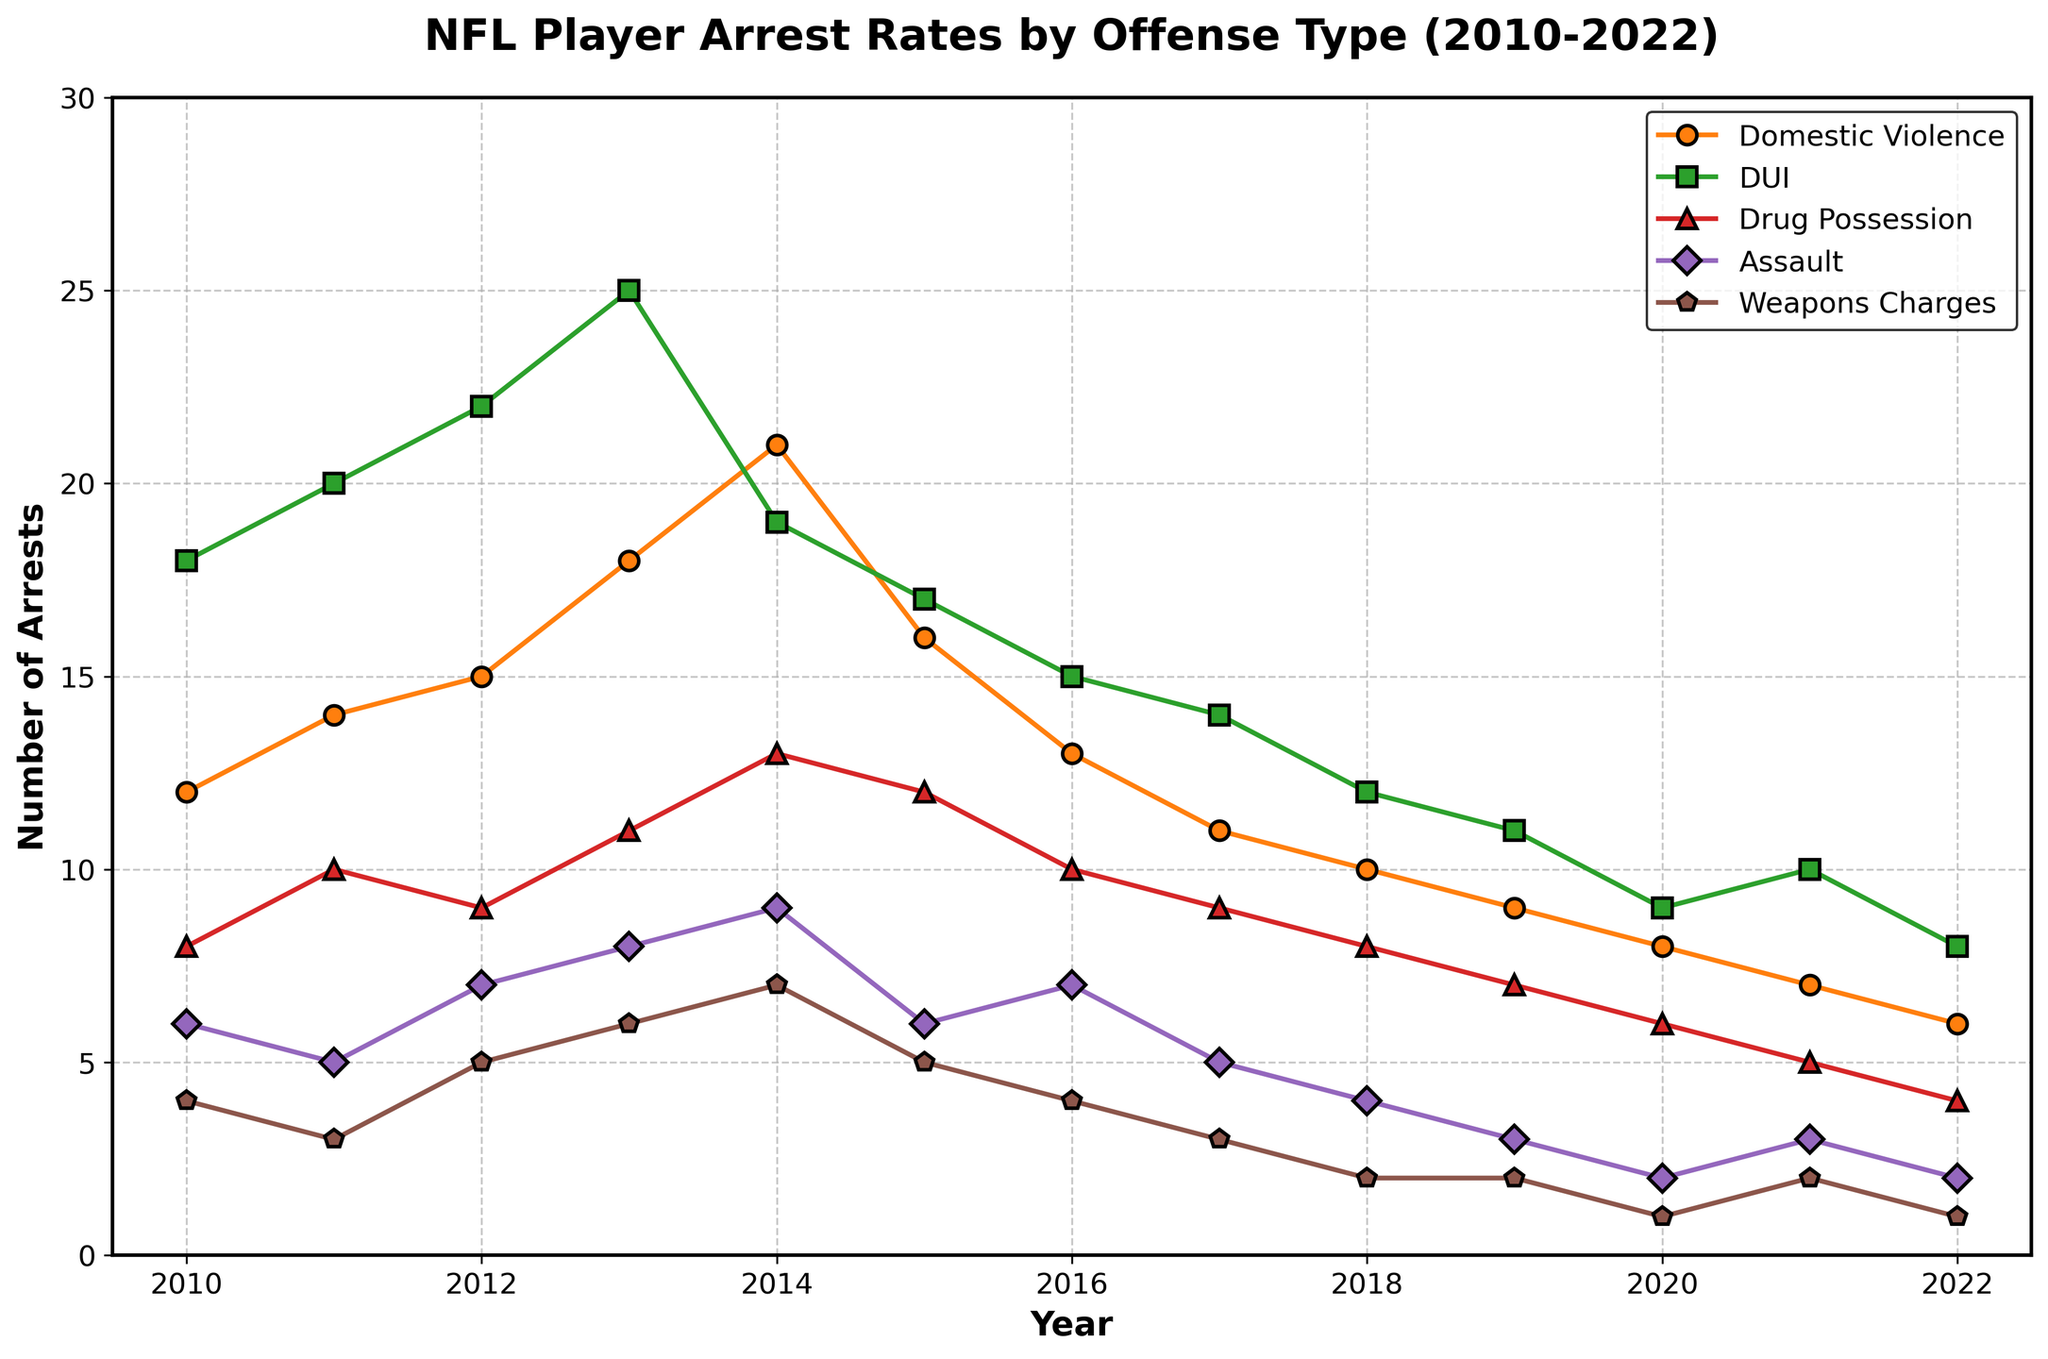How did the number of DUI arrests change from 2010 to 2022? To find the change in the number of DUI arrests, subtract the number of arrests in 2022 (8) from the number of arrests in 2010 (18). 18 - 8 = 10.
Answer: The number of DUI arrests decreased by 10 Which offense had the highest arrest rate in 2013? Examine the peak values for each offense in 2013. Domestic Violence had 18, DUI had 25, Drug Possession had 11, Assault had 8, and Weapons Charges had 6. The highest value is 25 for DUI.
Answer: DUI What is the sum of Domestic Violence arrests from 2010 to 2015? Add the number of Domestic Violence arrests for each year from 2010 to 2015: 12 + 14 + 15 + 18 + 21 + 16 = 96.
Answer: 96 Which offense consistently shows the lowest number of arrests each year? Compare the number of arrests for each offense across all years. Weapons Charges has the lowest arrest numbers in each year (4, 3, 5, 6, 7, 5, 4, 3, 2, 2, 1, 2, 1).
Answer: Weapons Charges In which year did Assault arrests show the largest decrease from the previous year? Compare the decline in Assault arrests year over year. The largest decline is between 2019 (3 arrests) and 2020 (2 arrests), which is 1 arrest. However, comparing 2018 (4) to 2019 (3) shows a decrease of 1 as well. Nonetheless, 2015 (6) to 2016 (7), a decrease of 1 arrest stands out. The most significant decline of 3, however, is between 2014 and 2015 (9 to 6 arrests).
Answer: 2015 Which years had fewer than 10 Drug Possession arrests? Identify the years with less than 10 Drug Possession arrests: 2010 (8), 2018 (8), 2019 (7), 2020 (6), 2021 (5), and 2022 (4).
Answer: 2010, 2018, 2019, 2020, 2021, 2022 What is the average number of Weapons Charges arrests for the years 2010-2015? Sum the number of Weapons Charges arrests for 2010-2015: 4 + 3 + 5 + 6 + 7 + 5 = 30. Divide by the number of years (6). 30 / 6 = 5.
Answer: 5 Which year had the highest total number of arrests combining all offenses? Add the total number of arrests for each year and find the highest. 2010: (12+18+8+6+4)=48, 2011: (14+20+10+5+3)=52, 2012: (15+22+9+7+5)=58, 2013: (18+25+11+8+6)=68, 2014: (21+19+13+9+7)=69, 2015: (16+17+12+6+5)=56, 2016: (13+15+10+7+4)=49, 2017: (11+14+9+5+3)=42, 2018: (10+12+8+4+2)=36, 2019: (9+11+7+3+2)=32, 2020: (8+9+6+2+1)=26, 2021: (7+10+5+3+2)=27, 2022: (6+8+4+2+1)=21. The highest is 2014 with 69 total arrests.
Answer: 2014 